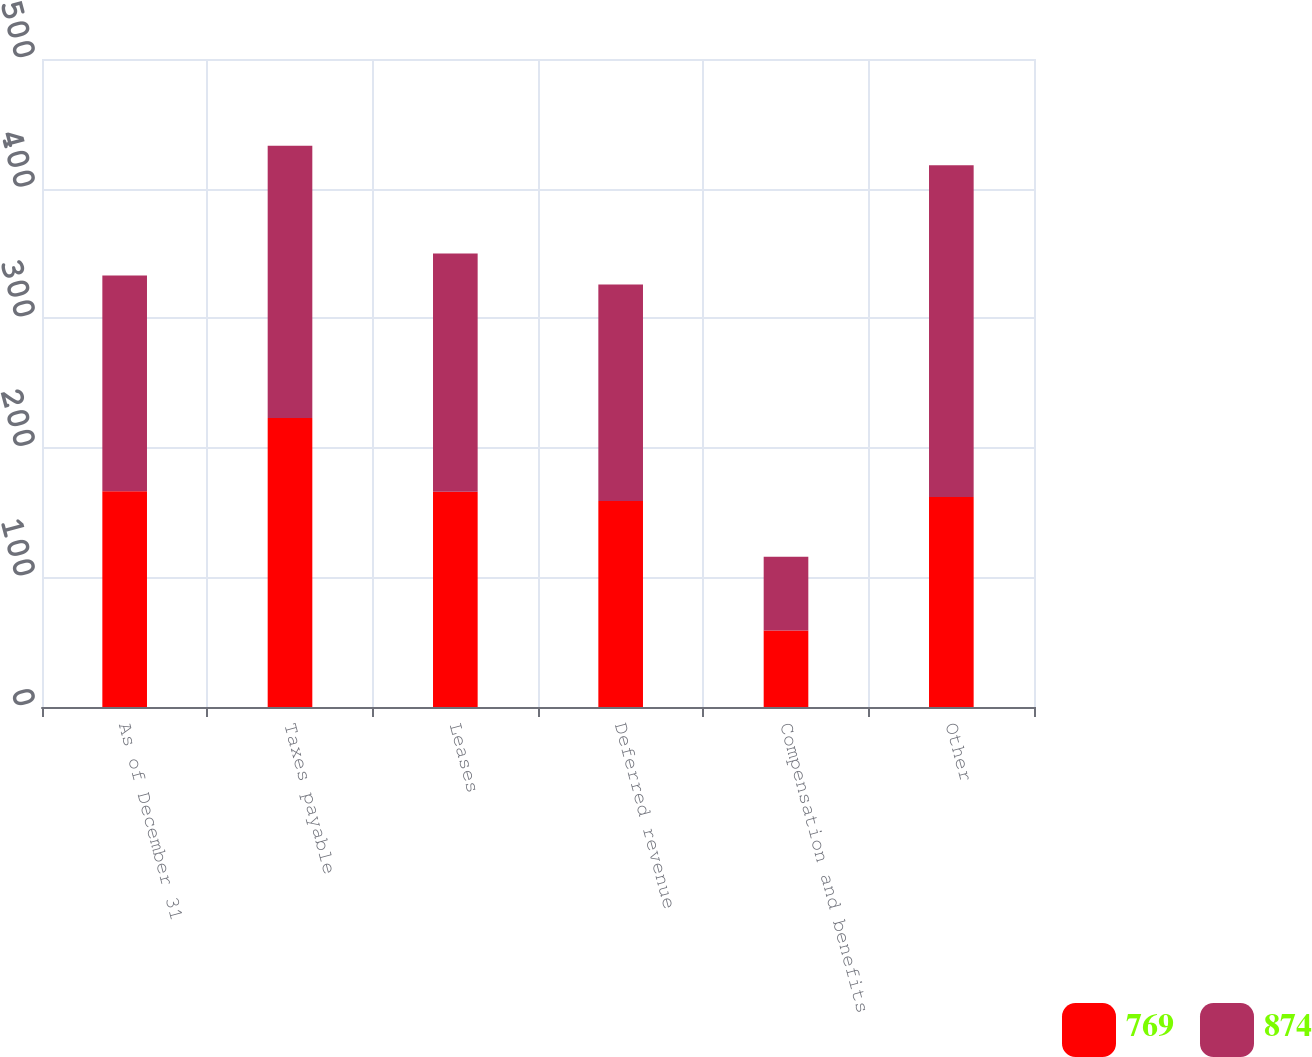Convert chart. <chart><loc_0><loc_0><loc_500><loc_500><stacked_bar_chart><ecel><fcel>As of December 31<fcel>Taxes payable<fcel>Leases<fcel>Deferred revenue<fcel>Compensation and benefits<fcel>Other<nl><fcel>769<fcel>166.5<fcel>223<fcel>166<fcel>159<fcel>59<fcel>162<nl><fcel>874<fcel>166.5<fcel>210<fcel>184<fcel>167<fcel>57<fcel>256<nl></chart> 